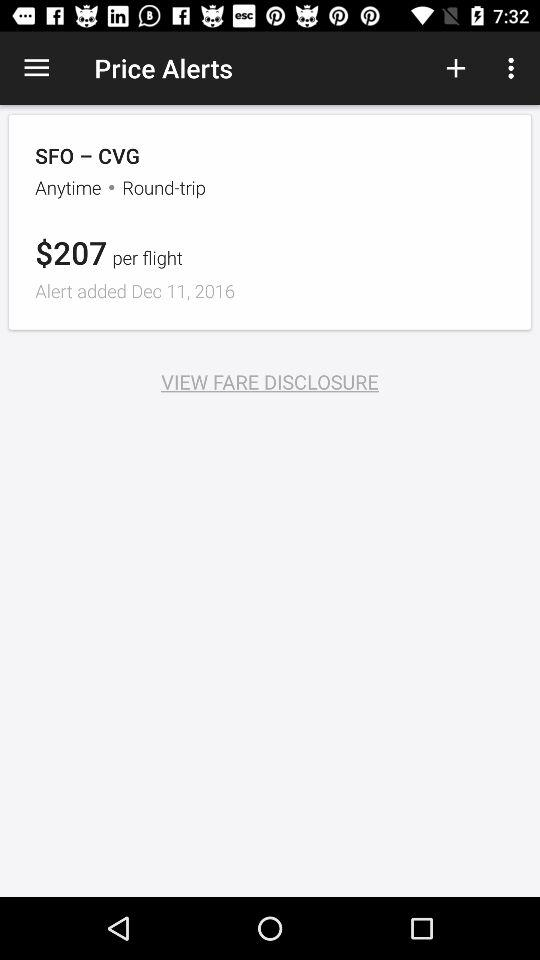How much does a one-way flight cost?
When the provided information is insufficient, respond with <no answer>. <no answer> 